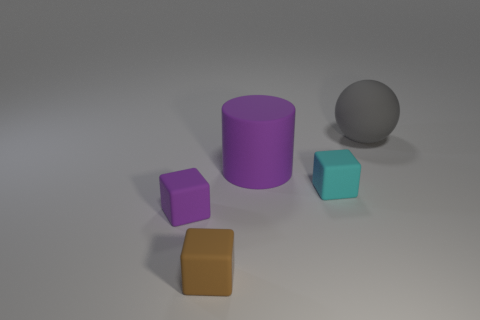Add 2 small brown rubber blocks. How many objects exist? 7 Subtract all red cubes. Subtract all gray cylinders. How many cubes are left? 3 Subtract all cylinders. How many objects are left? 4 Subtract 1 brown blocks. How many objects are left? 4 Subtract all brown rubber blocks. Subtract all small gray blocks. How many objects are left? 4 Add 4 big gray matte objects. How many big gray matte objects are left? 5 Add 4 small purple shiny cubes. How many small purple shiny cubes exist? 4 